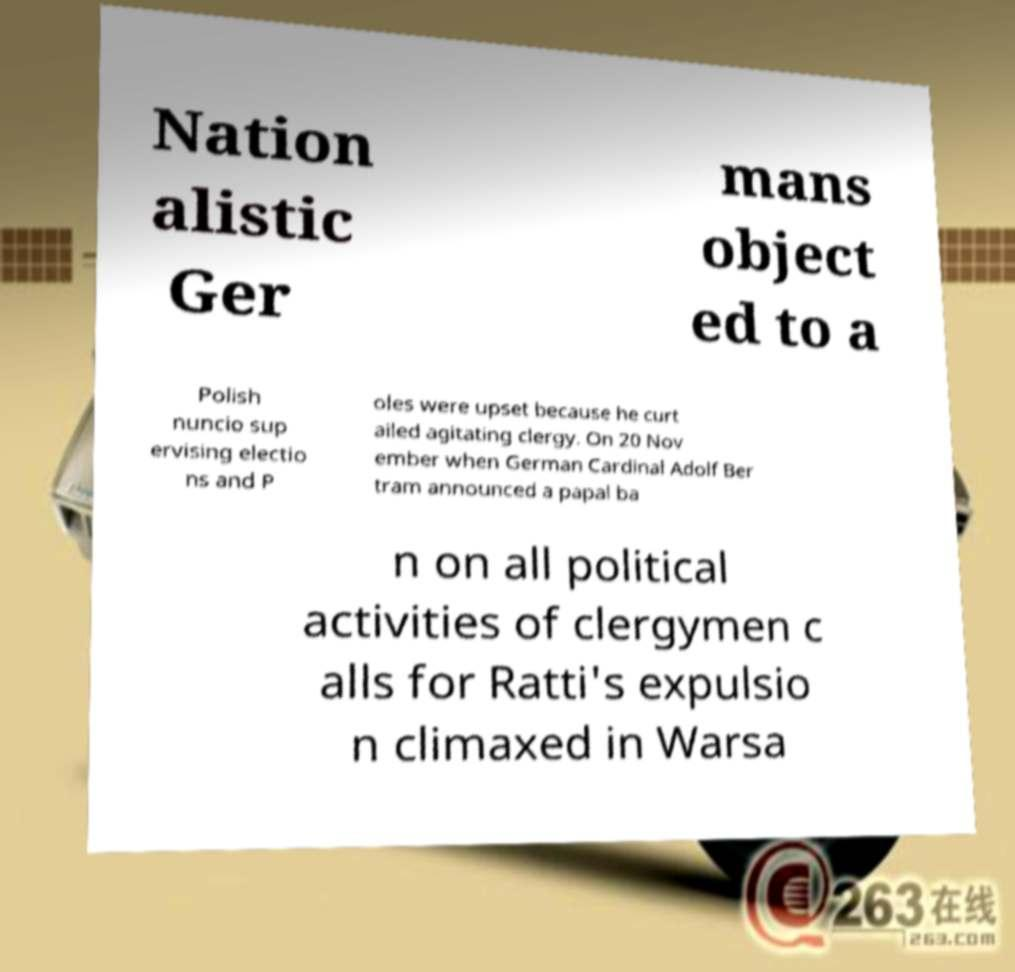What messages or text are displayed in this image? I need them in a readable, typed format. Nation alistic Ger mans object ed to a Polish nuncio sup ervising electio ns and P oles were upset because he curt ailed agitating clergy. On 20 Nov ember when German Cardinal Adolf Ber tram announced a papal ba n on all political activities of clergymen c alls for Ratti's expulsio n climaxed in Warsa 